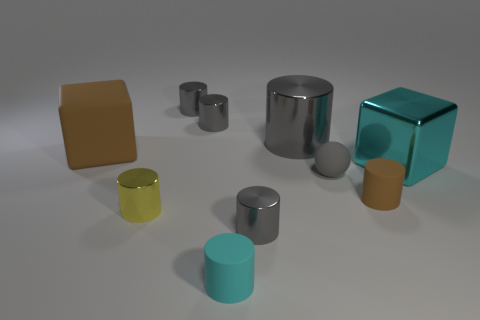Is the color of the matte ball the same as the big metallic object left of the shiny cube?
Give a very brief answer. Yes. Is the big metallic cylinder the same color as the small matte sphere?
Ensure brevity in your answer.  Yes. Are there fewer yellow cylinders than tiny things?
Your response must be concise. Yes. What number of other things are there of the same color as the tiny sphere?
Your answer should be very brief. 4. What number of yellow metal cylinders are there?
Provide a short and direct response. 1. Are there fewer big cyan metal things to the left of the small yellow shiny object than small green spheres?
Give a very brief answer. No. Do the small gray object right of the big gray object and the big gray cylinder have the same material?
Make the answer very short. No. What is the shape of the brown matte thing that is in front of the large block that is behind the large shiny thing that is in front of the large brown block?
Provide a succinct answer. Cylinder. Is there another cyan rubber object that has the same size as the cyan rubber object?
Your answer should be compact. No. What is the size of the gray ball?
Ensure brevity in your answer.  Small. 